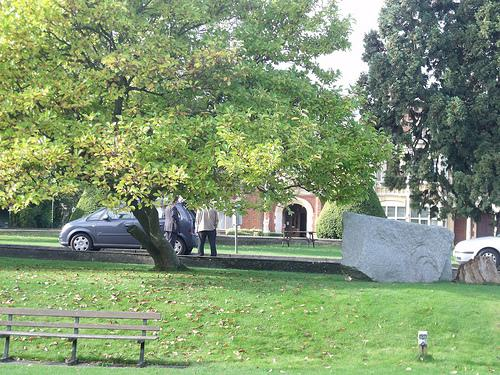Question: how many people are shown?
Choices:
A. Four.
B. Two.
C. Five.
D. Nine.
Answer with the letter. Answer: B Question: what is behind the rock?
Choices:
A. A cat.
B. A dog.
C. Vehicle.
D. A person.
Answer with the letter. Answer: C Question: what is in front of the grass?
Choices:
A. A chair.
B. Bench.
C. A sofa.
D. A desk.
Answer with the letter. Answer: B Question: who is talking behind the blue vehicle?
Choices:
A. Three women.
B. Two men.
C. Four little girls.
D. Eight teenagers.
Answer with the letter. Answer: B 